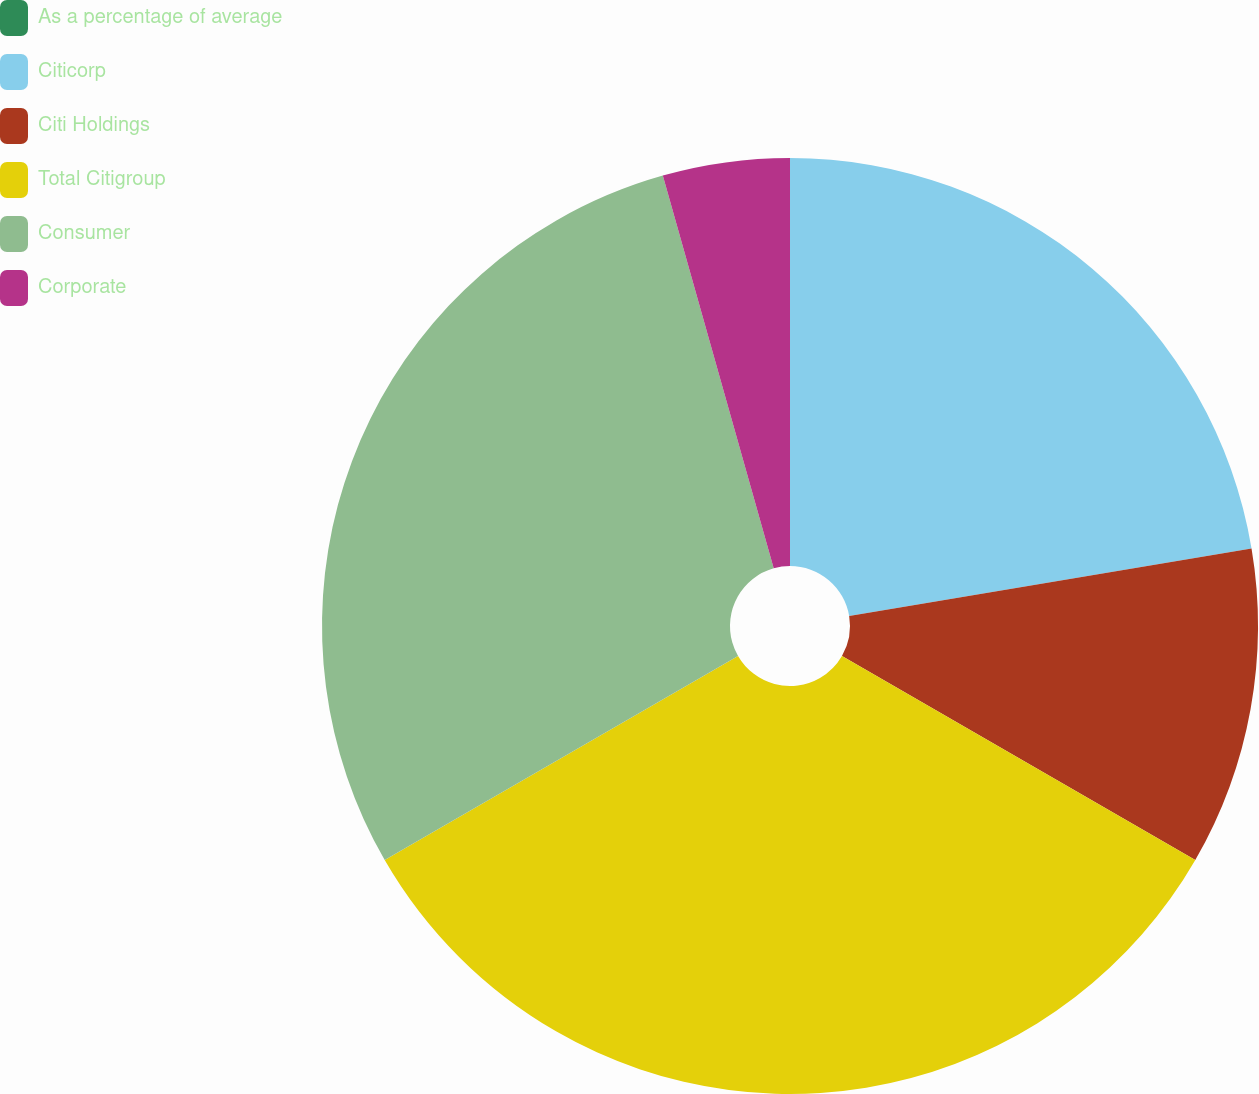Convert chart. <chart><loc_0><loc_0><loc_500><loc_500><pie_chart><fcel>As a percentage of average<fcel>Citicorp<fcel>Citi Holdings<fcel>Total Citigroup<fcel>Consumer<fcel>Corporate<nl><fcel>0.0%<fcel>22.35%<fcel>10.98%<fcel>33.33%<fcel>28.95%<fcel>4.38%<nl></chart> 